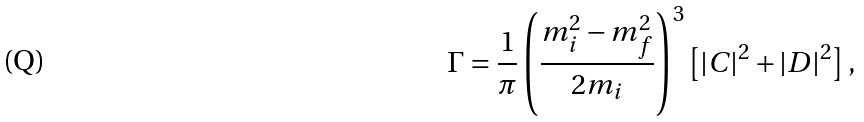Convert formula to latex. <formula><loc_0><loc_0><loc_500><loc_500>\Gamma = \frac { 1 } { \pi } \left ( \frac { m ^ { 2 } _ { i } - m ^ { 2 } _ { f } } { 2 m _ { i } } \right ) ^ { 3 } \left [ | C | ^ { 2 } + | D | ^ { 2 } \right ] ,</formula> 